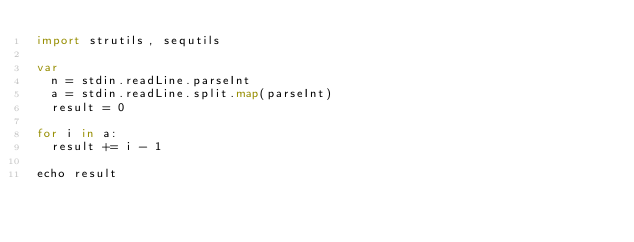Convert code to text. <code><loc_0><loc_0><loc_500><loc_500><_Nim_>import strutils, sequtils

var
  n = stdin.readLine.parseInt
  a = stdin.readLine.split.map(parseInt)
  result = 0

for i in a:
  result += i - 1

echo result</code> 